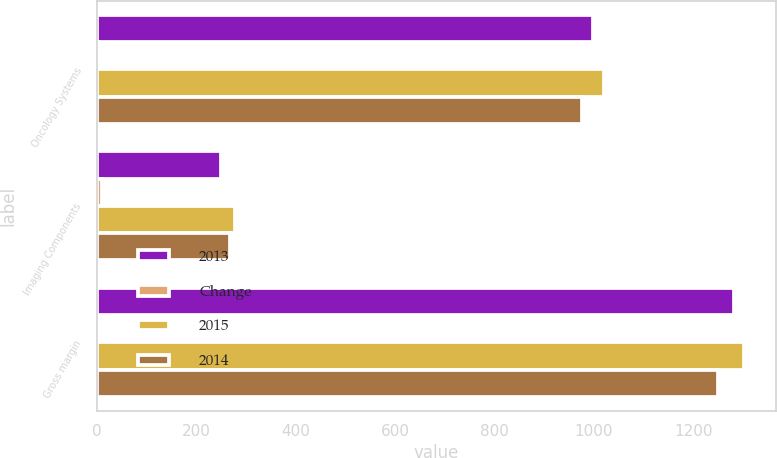Convert chart. <chart><loc_0><loc_0><loc_500><loc_500><stacked_bar_chart><ecel><fcel>Oncology Systems<fcel>Imaging Components<fcel>Gross margin<nl><fcel>2013<fcel>998.9<fcel>250.6<fcel>1282.7<nl><fcel>Change<fcel>2<fcel>10<fcel>1<nl><fcel>2015<fcel>1021.1<fcel>278.6<fcel>1301.7<nl><fcel>2014<fcel>976.2<fcel>268.1<fcel>1249.7<nl></chart> 